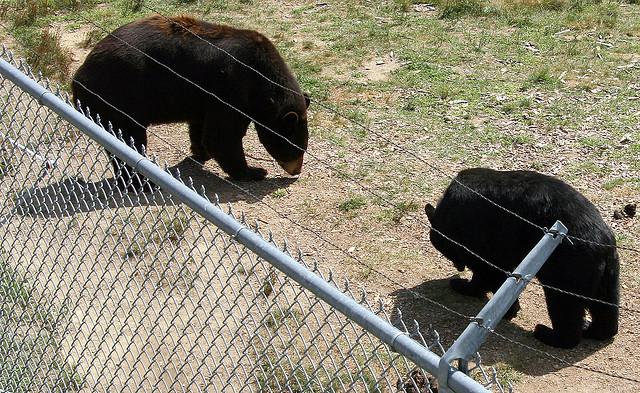What are the bears doing?
Give a very brief answer. Eating. Are the bears walking towards each other?
Be succinct. Yes. What extra precaution is at the top of the fence?
Write a very short answer. Barbed wire. 